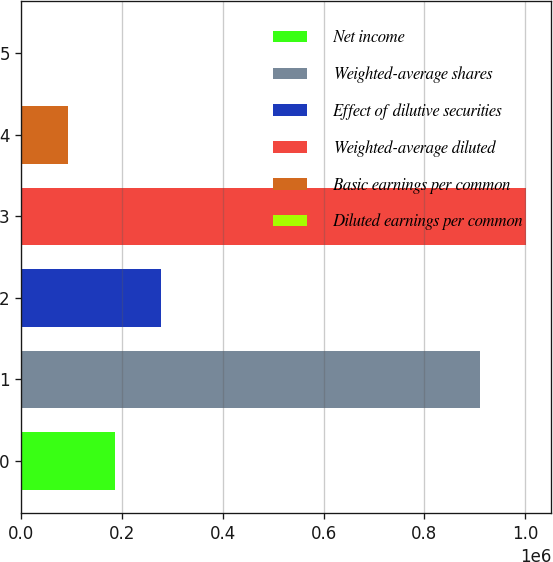Convert chart. <chart><loc_0><loc_0><loc_500><loc_500><bar_chart><fcel>Net income<fcel>Weighted-average shares<fcel>Effect of dilutive securities<fcel>Weighted-average diluted<fcel>Basic earnings per common<fcel>Diluted earnings per common<nl><fcel>184955<fcel>909461<fcel>277424<fcel>1.00193e+06<fcel>92484.8<fcel>15.15<nl></chart> 